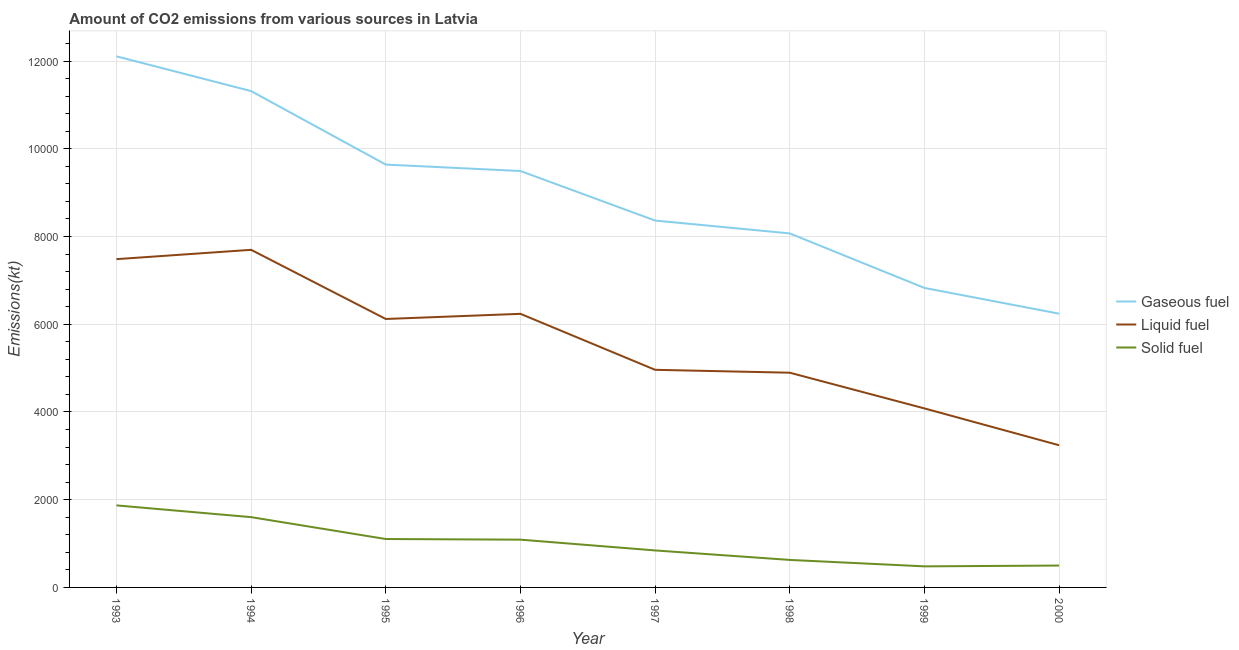What is the amount of co2 emissions from solid fuel in 1998?
Offer a terse response. 627.06. Across all years, what is the maximum amount of co2 emissions from gaseous fuel?
Give a very brief answer. 1.21e+04. Across all years, what is the minimum amount of co2 emissions from gaseous fuel?
Your response must be concise. 6241.23. In which year was the amount of co2 emissions from solid fuel minimum?
Make the answer very short. 1999. What is the total amount of co2 emissions from gaseous fuel in the graph?
Offer a terse response. 7.21e+04. What is the difference between the amount of co2 emissions from solid fuel in 1997 and that in 1999?
Your answer should be compact. 363.03. What is the difference between the amount of co2 emissions from solid fuel in 1994 and the amount of co2 emissions from gaseous fuel in 1998?
Keep it short and to the point. -6468.59. What is the average amount of co2 emissions from gaseous fuel per year?
Keep it short and to the point. 9007.99. In the year 1996, what is the difference between the amount of co2 emissions from solid fuel and amount of co2 emissions from liquid fuel?
Offer a very short reply. -5148.47. In how many years, is the amount of co2 emissions from liquid fuel greater than 12000 kt?
Keep it short and to the point. 0. What is the ratio of the amount of co2 emissions from gaseous fuel in 1994 to that in 1995?
Provide a short and direct response. 1.17. Is the amount of co2 emissions from liquid fuel in 1998 less than that in 1999?
Provide a succinct answer. No. Is the difference between the amount of co2 emissions from gaseous fuel in 1994 and 1997 greater than the difference between the amount of co2 emissions from solid fuel in 1994 and 1997?
Your answer should be compact. Yes. What is the difference between the highest and the second highest amount of co2 emissions from liquid fuel?
Give a very brief answer. 212.69. What is the difference between the highest and the lowest amount of co2 emissions from solid fuel?
Your response must be concise. 1389.79. Is the sum of the amount of co2 emissions from liquid fuel in 1995 and 1997 greater than the maximum amount of co2 emissions from solid fuel across all years?
Offer a terse response. Yes. Is the amount of co2 emissions from gaseous fuel strictly greater than the amount of co2 emissions from solid fuel over the years?
Ensure brevity in your answer.  Yes. What is the difference between two consecutive major ticks on the Y-axis?
Your answer should be compact. 2000. Are the values on the major ticks of Y-axis written in scientific E-notation?
Give a very brief answer. No. Does the graph contain any zero values?
Provide a short and direct response. No. Where does the legend appear in the graph?
Your answer should be very brief. Center right. How many legend labels are there?
Offer a very short reply. 3. What is the title of the graph?
Offer a terse response. Amount of CO2 emissions from various sources in Latvia. Does "Oil" appear as one of the legend labels in the graph?
Your answer should be compact. No. What is the label or title of the X-axis?
Your response must be concise. Year. What is the label or title of the Y-axis?
Keep it short and to the point. Emissions(kt). What is the Emissions(kt) in Gaseous fuel in 1993?
Keep it short and to the point. 1.21e+04. What is the Emissions(kt) of Liquid fuel in 1993?
Your response must be concise. 7484.35. What is the Emissions(kt) of Solid fuel in 1993?
Offer a very short reply. 1870.17. What is the Emissions(kt) of Gaseous fuel in 1994?
Provide a short and direct response. 1.13e+04. What is the Emissions(kt) in Liquid fuel in 1994?
Offer a terse response. 7697.03. What is the Emissions(kt) of Solid fuel in 1994?
Make the answer very short. 1602.48. What is the Emissions(kt) of Gaseous fuel in 1995?
Your response must be concise. 9640.54. What is the Emissions(kt) of Liquid fuel in 1995?
Provide a succinct answer. 6120.22. What is the Emissions(kt) in Solid fuel in 1995?
Offer a terse response. 1103.77. What is the Emissions(kt) of Gaseous fuel in 1996?
Your answer should be very brief. 9493.86. What is the Emissions(kt) in Liquid fuel in 1996?
Provide a succinct answer. 6237.57. What is the Emissions(kt) of Solid fuel in 1996?
Keep it short and to the point. 1089.1. What is the Emissions(kt) in Gaseous fuel in 1997?
Offer a very short reply. 8364.43. What is the Emissions(kt) in Liquid fuel in 1997?
Keep it short and to the point. 4961.45. What is the Emissions(kt) of Solid fuel in 1997?
Your answer should be very brief. 843.41. What is the Emissions(kt) in Gaseous fuel in 1998?
Give a very brief answer. 8071.07. What is the Emissions(kt) in Liquid fuel in 1998?
Keep it short and to the point. 4895.44. What is the Emissions(kt) of Solid fuel in 1998?
Your response must be concise. 627.06. What is the Emissions(kt) in Gaseous fuel in 1999?
Your answer should be compact. 6827.95. What is the Emissions(kt) in Liquid fuel in 1999?
Give a very brief answer. 4081.37. What is the Emissions(kt) of Solid fuel in 1999?
Keep it short and to the point. 480.38. What is the Emissions(kt) of Gaseous fuel in 2000?
Your response must be concise. 6241.23. What is the Emissions(kt) in Liquid fuel in 2000?
Give a very brief answer. 3241.63. What is the Emissions(kt) in Solid fuel in 2000?
Your answer should be very brief. 498.71. Across all years, what is the maximum Emissions(kt) of Gaseous fuel?
Your response must be concise. 1.21e+04. Across all years, what is the maximum Emissions(kt) of Liquid fuel?
Give a very brief answer. 7697.03. Across all years, what is the maximum Emissions(kt) in Solid fuel?
Offer a very short reply. 1870.17. Across all years, what is the minimum Emissions(kt) in Gaseous fuel?
Ensure brevity in your answer.  6241.23. Across all years, what is the minimum Emissions(kt) of Liquid fuel?
Your response must be concise. 3241.63. Across all years, what is the minimum Emissions(kt) in Solid fuel?
Offer a very short reply. 480.38. What is the total Emissions(kt) of Gaseous fuel in the graph?
Make the answer very short. 7.21e+04. What is the total Emissions(kt) in Liquid fuel in the graph?
Offer a terse response. 4.47e+04. What is the total Emissions(kt) in Solid fuel in the graph?
Your answer should be very brief. 8115.07. What is the difference between the Emissions(kt) in Gaseous fuel in 1993 and that in 1994?
Offer a very short reply. 792.07. What is the difference between the Emissions(kt) of Liquid fuel in 1993 and that in 1994?
Your answer should be compact. -212.69. What is the difference between the Emissions(kt) in Solid fuel in 1993 and that in 1994?
Your answer should be very brief. 267.69. What is the difference between the Emissions(kt) of Gaseous fuel in 1993 and that in 1995?
Ensure brevity in your answer.  2467.89. What is the difference between the Emissions(kt) in Liquid fuel in 1993 and that in 1995?
Offer a very short reply. 1364.12. What is the difference between the Emissions(kt) in Solid fuel in 1993 and that in 1995?
Offer a terse response. 766.4. What is the difference between the Emissions(kt) of Gaseous fuel in 1993 and that in 1996?
Your answer should be compact. 2614.57. What is the difference between the Emissions(kt) of Liquid fuel in 1993 and that in 1996?
Ensure brevity in your answer.  1246.78. What is the difference between the Emissions(kt) in Solid fuel in 1993 and that in 1996?
Provide a short and direct response. 781.07. What is the difference between the Emissions(kt) in Gaseous fuel in 1993 and that in 1997?
Offer a very short reply. 3744.01. What is the difference between the Emissions(kt) in Liquid fuel in 1993 and that in 1997?
Give a very brief answer. 2522.9. What is the difference between the Emissions(kt) of Solid fuel in 1993 and that in 1997?
Make the answer very short. 1026.76. What is the difference between the Emissions(kt) in Gaseous fuel in 1993 and that in 1998?
Offer a very short reply. 4037.37. What is the difference between the Emissions(kt) of Liquid fuel in 1993 and that in 1998?
Your answer should be compact. 2588.9. What is the difference between the Emissions(kt) of Solid fuel in 1993 and that in 1998?
Ensure brevity in your answer.  1243.11. What is the difference between the Emissions(kt) of Gaseous fuel in 1993 and that in 1999?
Offer a terse response. 5280.48. What is the difference between the Emissions(kt) of Liquid fuel in 1993 and that in 1999?
Your answer should be compact. 3402.98. What is the difference between the Emissions(kt) of Solid fuel in 1993 and that in 1999?
Provide a succinct answer. 1389.79. What is the difference between the Emissions(kt) of Gaseous fuel in 1993 and that in 2000?
Your answer should be compact. 5867.2. What is the difference between the Emissions(kt) in Liquid fuel in 1993 and that in 2000?
Offer a very short reply. 4242.72. What is the difference between the Emissions(kt) in Solid fuel in 1993 and that in 2000?
Provide a succinct answer. 1371.46. What is the difference between the Emissions(kt) in Gaseous fuel in 1994 and that in 1995?
Your response must be concise. 1675.82. What is the difference between the Emissions(kt) of Liquid fuel in 1994 and that in 1995?
Make the answer very short. 1576.81. What is the difference between the Emissions(kt) in Solid fuel in 1994 and that in 1995?
Your answer should be very brief. 498.71. What is the difference between the Emissions(kt) in Gaseous fuel in 1994 and that in 1996?
Provide a succinct answer. 1822.5. What is the difference between the Emissions(kt) of Liquid fuel in 1994 and that in 1996?
Ensure brevity in your answer.  1459.47. What is the difference between the Emissions(kt) in Solid fuel in 1994 and that in 1996?
Ensure brevity in your answer.  513.38. What is the difference between the Emissions(kt) in Gaseous fuel in 1994 and that in 1997?
Your response must be concise. 2951.93. What is the difference between the Emissions(kt) of Liquid fuel in 1994 and that in 1997?
Provide a short and direct response. 2735.58. What is the difference between the Emissions(kt) of Solid fuel in 1994 and that in 1997?
Make the answer very short. 759.07. What is the difference between the Emissions(kt) of Gaseous fuel in 1994 and that in 1998?
Provide a short and direct response. 3245.3. What is the difference between the Emissions(kt) in Liquid fuel in 1994 and that in 1998?
Give a very brief answer. 2801.59. What is the difference between the Emissions(kt) in Solid fuel in 1994 and that in 1998?
Ensure brevity in your answer.  975.42. What is the difference between the Emissions(kt) in Gaseous fuel in 1994 and that in 1999?
Give a very brief answer. 4488.41. What is the difference between the Emissions(kt) of Liquid fuel in 1994 and that in 1999?
Offer a terse response. 3615.66. What is the difference between the Emissions(kt) of Solid fuel in 1994 and that in 1999?
Give a very brief answer. 1122.1. What is the difference between the Emissions(kt) in Gaseous fuel in 1994 and that in 2000?
Offer a terse response. 5075.13. What is the difference between the Emissions(kt) of Liquid fuel in 1994 and that in 2000?
Make the answer very short. 4455.4. What is the difference between the Emissions(kt) of Solid fuel in 1994 and that in 2000?
Provide a short and direct response. 1103.77. What is the difference between the Emissions(kt) in Gaseous fuel in 1995 and that in 1996?
Give a very brief answer. 146.68. What is the difference between the Emissions(kt) of Liquid fuel in 1995 and that in 1996?
Offer a terse response. -117.34. What is the difference between the Emissions(kt) of Solid fuel in 1995 and that in 1996?
Your response must be concise. 14.67. What is the difference between the Emissions(kt) of Gaseous fuel in 1995 and that in 1997?
Your answer should be compact. 1276.12. What is the difference between the Emissions(kt) in Liquid fuel in 1995 and that in 1997?
Your answer should be compact. 1158.77. What is the difference between the Emissions(kt) in Solid fuel in 1995 and that in 1997?
Ensure brevity in your answer.  260.36. What is the difference between the Emissions(kt) in Gaseous fuel in 1995 and that in 1998?
Offer a very short reply. 1569.48. What is the difference between the Emissions(kt) in Liquid fuel in 1995 and that in 1998?
Ensure brevity in your answer.  1224.78. What is the difference between the Emissions(kt) in Solid fuel in 1995 and that in 1998?
Provide a succinct answer. 476.71. What is the difference between the Emissions(kt) in Gaseous fuel in 1995 and that in 1999?
Ensure brevity in your answer.  2812.59. What is the difference between the Emissions(kt) of Liquid fuel in 1995 and that in 1999?
Ensure brevity in your answer.  2038.85. What is the difference between the Emissions(kt) in Solid fuel in 1995 and that in 1999?
Ensure brevity in your answer.  623.39. What is the difference between the Emissions(kt) of Gaseous fuel in 1995 and that in 2000?
Your answer should be compact. 3399.31. What is the difference between the Emissions(kt) of Liquid fuel in 1995 and that in 2000?
Provide a succinct answer. 2878.59. What is the difference between the Emissions(kt) of Solid fuel in 1995 and that in 2000?
Provide a succinct answer. 605.05. What is the difference between the Emissions(kt) in Gaseous fuel in 1996 and that in 1997?
Provide a short and direct response. 1129.44. What is the difference between the Emissions(kt) in Liquid fuel in 1996 and that in 1997?
Your answer should be very brief. 1276.12. What is the difference between the Emissions(kt) in Solid fuel in 1996 and that in 1997?
Your answer should be very brief. 245.69. What is the difference between the Emissions(kt) of Gaseous fuel in 1996 and that in 1998?
Your answer should be very brief. 1422.8. What is the difference between the Emissions(kt) of Liquid fuel in 1996 and that in 1998?
Give a very brief answer. 1342.12. What is the difference between the Emissions(kt) of Solid fuel in 1996 and that in 1998?
Offer a terse response. 462.04. What is the difference between the Emissions(kt) of Gaseous fuel in 1996 and that in 1999?
Keep it short and to the point. 2665.91. What is the difference between the Emissions(kt) in Liquid fuel in 1996 and that in 1999?
Your answer should be compact. 2156.2. What is the difference between the Emissions(kt) in Solid fuel in 1996 and that in 1999?
Your answer should be compact. 608.72. What is the difference between the Emissions(kt) of Gaseous fuel in 1996 and that in 2000?
Offer a terse response. 3252.63. What is the difference between the Emissions(kt) of Liquid fuel in 1996 and that in 2000?
Offer a terse response. 2995.94. What is the difference between the Emissions(kt) of Solid fuel in 1996 and that in 2000?
Provide a short and direct response. 590.39. What is the difference between the Emissions(kt) of Gaseous fuel in 1997 and that in 1998?
Ensure brevity in your answer.  293.36. What is the difference between the Emissions(kt) of Liquid fuel in 1997 and that in 1998?
Your response must be concise. 66.01. What is the difference between the Emissions(kt) in Solid fuel in 1997 and that in 1998?
Make the answer very short. 216.35. What is the difference between the Emissions(kt) in Gaseous fuel in 1997 and that in 1999?
Your answer should be very brief. 1536.47. What is the difference between the Emissions(kt) of Liquid fuel in 1997 and that in 1999?
Give a very brief answer. 880.08. What is the difference between the Emissions(kt) of Solid fuel in 1997 and that in 1999?
Make the answer very short. 363.03. What is the difference between the Emissions(kt) in Gaseous fuel in 1997 and that in 2000?
Your answer should be compact. 2123.19. What is the difference between the Emissions(kt) of Liquid fuel in 1997 and that in 2000?
Your response must be concise. 1719.82. What is the difference between the Emissions(kt) in Solid fuel in 1997 and that in 2000?
Your answer should be compact. 344.7. What is the difference between the Emissions(kt) of Gaseous fuel in 1998 and that in 1999?
Your response must be concise. 1243.11. What is the difference between the Emissions(kt) of Liquid fuel in 1998 and that in 1999?
Offer a very short reply. 814.07. What is the difference between the Emissions(kt) of Solid fuel in 1998 and that in 1999?
Give a very brief answer. 146.68. What is the difference between the Emissions(kt) of Gaseous fuel in 1998 and that in 2000?
Provide a succinct answer. 1829.83. What is the difference between the Emissions(kt) of Liquid fuel in 1998 and that in 2000?
Provide a succinct answer. 1653.82. What is the difference between the Emissions(kt) of Solid fuel in 1998 and that in 2000?
Offer a terse response. 128.34. What is the difference between the Emissions(kt) in Gaseous fuel in 1999 and that in 2000?
Offer a very short reply. 586.72. What is the difference between the Emissions(kt) of Liquid fuel in 1999 and that in 2000?
Give a very brief answer. 839.74. What is the difference between the Emissions(kt) of Solid fuel in 1999 and that in 2000?
Offer a terse response. -18.34. What is the difference between the Emissions(kt) in Gaseous fuel in 1993 and the Emissions(kt) in Liquid fuel in 1994?
Offer a terse response. 4411.4. What is the difference between the Emissions(kt) of Gaseous fuel in 1993 and the Emissions(kt) of Solid fuel in 1994?
Your response must be concise. 1.05e+04. What is the difference between the Emissions(kt) of Liquid fuel in 1993 and the Emissions(kt) of Solid fuel in 1994?
Make the answer very short. 5881.87. What is the difference between the Emissions(kt) of Gaseous fuel in 1993 and the Emissions(kt) of Liquid fuel in 1995?
Your response must be concise. 5988.21. What is the difference between the Emissions(kt) in Gaseous fuel in 1993 and the Emissions(kt) in Solid fuel in 1995?
Make the answer very short. 1.10e+04. What is the difference between the Emissions(kt) in Liquid fuel in 1993 and the Emissions(kt) in Solid fuel in 1995?
Provide a short and direct response. 6380.58. What is the difference between the Emissions(kt) in Gaseous fuel in 1993 and the Emissions(kt) in Liquid fuel in 1996?
Your response must be concise. 5870.87. What is the difference between the Emissions(kt) in Gaseous fuel in 1993 and the Emissions(kt) in Solid fuel in 1996?
Ensure brevity in your answer.  1.10e+04. What is the difference between the Emissions(kt) in Liquid fuel in 1993 and the Emissions(kt) in Solid fuel in 1996?
Provide a succinct answer. 6395.25. What is the difference between the Emissions(kt) in Gaseous fuel in 1993 and the Emissions(kt) in Liquid fuel in 1997?
Provide a short and direct response. 7146.98. What is the difference between the Emissions(kt) of Gaseous fuel in 1993 and the Emissions(kt) of Solid fuel in 1997?
Give a very brief answer. 1.13e+04. What is the difference between the Emissions(kt) in Liquid fuel in 1993 and the Emissions(kt) in Solid fuel in 1997?
Your answer should be very brief. 6640.94. What is the difference between the Emissions(kt) of Gaseous fuel in 1993 and the Emissions(kt) of Liquid fuel in 1998?
Ensure brevity in your answer.  7212.99. What is the difference between the Emissions(kt) of Gaseous fuel in 1993 and the Emissions(kt) of Solid fuel in 1998?
Provide a succinct answer. 1.15e+04. What is the difference between the Emissions(kt) in Liquid fuel in 1993 and the Emissions(kt) in Solid fuel in 1998?
Keep it short and to the point. 6857.29. What is the difference between the Emissions(kt) in Gaseous fuel in 1993 and the Emissions(kt) in Liquid fuel in 1999?
Give a very brief answer. 8027.06. What is the difference between the Emissions(kt) in Gaseous fuel in 1993 and the Emissions(kt) in Solid fuel in 1999?
Make the answer very short. 1.16e+04. What is the difference between the Emissions(kt) of Liquid fuel in 1993 and the Emissions(kt) of Solid fuel in 1999?
Provide a short and direct response. 7003.97. What is the difference between the Emissions(kt) in Gaseous fuel in 1993 and the Emissions(kt) in Liquid fuel in 2000?
Offer a very short reply. 8866.81. What is the difference between the Emissions(kt) in Gaseous fuel in 1993 and the Emissions(kt) in Solid fuel in 2000?
Offer a terse response. 1.16e+04. What is the difference between the Emissions(kt) in Liquid fuel in 1993 and the Emissions(kt) in Solid fuel in 2000?
Provide a short and direct response. 6985.64. What is the difference between the Emissions(kt) in Gaseous fuel in 1994 and the Emissions(kt) in Liquid fuel in 1995?
Keep it short and to the point. 5196.14. What is the difference between the Emissions(kt) of Gaseous fuel in 1994 and the Emissions(kt) of Solid fuel in 1995?
Give a very brief answer. 1.02e+04. What is the difference between the Emissions(kt) in Liquid fuel in 1994 and the Emissions(kt) in Solid fuel in 1995?
Make the answer very short. 6593.27. What is the difference between the Emissions(kt) of Gaseous fuel in 1994 and the Emissions(kt) of Liquid fuel in 1996?
Your answer should be compact. 5078.8. What is the difference between the Emissions(kt) in Gaseous fuel in 1994 and the Emissions(kt) in Solid fuel in 1996?
Ensure brevity in your answer.  1.02e+04. What is the difference between the Emissions(kt) in Liquid fuel in 1994 and the Emissions(kt) in Solid fuel in 1996?
Your response must be concise. 6607.93. What is the difference between the Emissions(kt) of Gaseous fuel in 1994 and the Emissions(kt) of Liquid fuel in 1997?
Provide a succinct answer. 6354.91. What is the difference between the Emissions(kt) of Gaseous fuel in 1994 and the Emissions(kt) of Solid fuel in 1997?
Your response must be concise. 1.05e+04. What is the difference between the Emissions(kt) of Liquid fuel in 1994 and the Emissions(kt) of Solid fuel in 1997?
Give a very brief answer. 6853.62. What is the difference between the Emissions(kt) of Gaseous fuel in 1994 and the Emissions(kt) of Liquid fuel in 1998?
Provide a short and direct response. 6420.92. What is the difference between the Emissions(kt) in Gaseous fuel in 1994 and the Emissions(kt) in Solid fuel in 1998?
Your answer should be very brief. 1.07e+04. What is the difference between the Emissions(kt) of Liquid fuel in 1994 and the Emissions(kt) of Solid fuel in 1998?
Your response must be concise. 7069.98. What is the difference between the Emissions(kt) in Gaseous fuel in 1994 and the Emissions(kt) in Liquid fuel in 1999?
Ensure brevity in your answer.  7234.99. What is the difference between the Emissions(kt) in Gaseous fuel in 1994 and the Emissions(kt) in Solid fuel in 1999?
Your answer should be compact. 1.08e+04. What is the difference between the Emissions(kt) in Liquid fuel in 1994 and the Emissions(kt) in Solid fuel in 1999?
Offer a terse response. 7216.66. What is the difference between the Emissions(kt) of Gaseous fuel in 1994 and the Emissions(kt) of Liquid fuel in 2000?
Offer a very short reply. 8074.73. What is the difference between the Emissions(kt) in Gaseous fuel in 1994 and the Emissions(kt) in Solid fuel in 2000?
Make the answer very short. 1.08e+04. What is the difference between the Emissions(kt) of Liquid fuel in 1994 and the Emissions(kt) of Solid fuel in 2000?
Your answer should be very brief. 7198.32. What is the difference between the Emissions(kt) of Gaseous fuel in 1995 and the Emissions(kt) of Liquid fuel in 1996?
Offer a terse response. 3402.98. What is the difference between the Emissions(kt) of Gaseous fuel in 1995 and the Emissions(kt) of Solid fuel in 1996?
Offer a very short reply. 8551.44. What is the difference between the Emissions(kt) of Liquid fuel in 1995 and the Emissions(kt) of Solid fuel in 1996?
Ensure brevity in your answer.  5031.12. What is the difference between the Emissions(kt) of Gaseous fuel in 1995 and the Emissions(kt) of Liquid fuel in 1997?
Your response must be concise. 4679.09. What is the difference between the Emissions(kt) of Gaseous fuel in 1995 and the Emissions(kt) of Solid fuel in 1997?
Provide a short and direct response. 8797.13. What is the difference between the Emissions(kt) of Liquid fuel in 1995 and the Emissions(kt) of Solid fuel in 1997?
Provide a succinct answer. 5276.81. What is the difference between the Emissions(kt) in Gaseous fuel in 1995 and the Emissions(kt) in Liquid fuel in 1998?
Ensure brevity in your answer.  4745.1. What is the difference between the Emissions(kt) of Gaseous fuel in 1995 and the Emissions(kt) of Solid fuel in 1998?
Ensure brevity in your answer.  9013.49. What is the difference between the Emissions(kt) of Liquid fuel in 1995 and the Emissions(kt) of Solid fuel in 1998?
Offer a terse response. 5493.17. What is the difference between the Emissions(kt) in Gaseous fuel in 1995 and the Emissions(kt) in Liquid fuel in 1999?
Your answer should be compact. 5559.17. What is the difference between the Emissions(kt) of Gaseous fuel in 1995 and the Emissions(kt) of Solid fuel in 1999?
Provide a short and direct response. 9160.17. What is the difference between the Emissions(kt) in Liquid fuel in 1995 and the Emissions(kt) in Solid fuel in 1999?
Provide a short and direct response. 5639.85. What is the difference between the Emissions(kt) of Gaseous fuel in 1995 and the Emissions(kt) of Liquid fuel in 2000?
Offer a terse response. 6398.91. What is the difference between the Emissions(kt) of Gaseous fuel in 1995 and the Emissions(kt) of Solid fuel in 2000?
Give a very brief answer. 9141.83. What is the difference between the Emissions(kt) of Liquid fuel in 1995 and the Emissions(kt) of Solid fuel in 2000?
Give a very brief answer. 5621.51. What is the difference between the Emissions(kt) in Gaseous fuel in 1996 and the Emissions(kt) in Liquid fuel in 1997?
Ensure brevity in your answer.  4532.41. What is the difference between the Emissions(kt) in Gaseous fuel in 1996 and the Emissions(kt) in Solid fuel in 1997?
Ensure brevity in your answer.  8650.45. What is the difference between the Emissions(kt) of Liquid fuel in 1996 and the Emissions(kt) of Solid fuel in 1997?
Provide a short and direct response. 5394.16. What is the difference between the Emissions(kt) in Gaseous fuel in 1996 and the Emissions(kt) in Liquid fuel in 1998?
Ensure brevity in your answer.  4598.42. What is the difference between the Emissions(kt) in Gaseous fuel in 1996 and the Emissions(kt) in Solid fuel in 1998?
Offer a terse response. 8866.81. What is the difference between the Emissions(kt) in Liquid fuel in 1996 and the Emissions(kt) in Solid fuel in 1998?
Provide a succinct answer. 5610.51. What is the difference between the Emissions(kt) of Gaseous fuel in 1996 and the Emissions(kt) of Liquid fuel in 1999?
Offer a very short reply. 5412.49. What is the difference between the Emissions(kt) in Gaseous fuel in 1996 and the Emissions(kt) in Solid fuel in 1999?
Provide a short and direct response. 9013.49. What is the difference between the Emissions(kt) in Liquid fuel in 1996 and the Emissions(kt) in Solid fuel in 1999?
Offer a terse response. 5757.19. What is the difference between the Emissions(kt) of Gaseous fuel in 1996 and the Emissions(kt) of Liquid fuel in 2000?
Ensure brevity in your answer.  6252.23. What is the difference between the Emissions(kt) of Gaseous fuel in 1996 and the Emissions(kt) of Solid fuel in 2000?
Your answer should be very brief. 8995.15. What is the difference between the Emissions(kt) of Liquid fuel in 1996 and the Emissions(kt) of Solid fuel in 2000?
Provide a short and direct response. 5738.85. What is the difference between the Emissions(kt) in Gaseous fuel in 1997 and the Emissions(kt) in Liquid fuel in 1998?
Offer a terse response. 3468.98. What is the difference between the Emissions(kt) of Gaseous fuel in 1997 and the Emissions(kt) of Solid fuel in 1998?
Keep it short and to the point. 7737.37. What is the difference between the Emissions(kt) of Liquid fuel in 1997 and the Emissions(kt) of Solid fuel in 1998?
Ensure brevity in your answer.  4334.39. What is the difference between the Emissions(kt) in Gaseous fuel in 1997 and the Emissions(kt) in Liquid fuel in 1999?
Your response must be concise. 4283.06. What is the difference between the Emissions(kt) in Gaseous fuel in 1997 and the Emissions(kt) in Solid fuel in 1999?
Your answer should be compact. 7884.05. What is the difference between the Emissions(kt) in Liquid fuel in 1997 and the Emissions(kt) in Solid fuel in 1999?
Keep it short and to the point. 4481.07. What is the difference between the Emissions(kt) of Gaseous fuel in 1997 and the Emissions(kt) of Liquid fuel in 2000?
Ensure brevity in your answer.  5122.8. What is the difference between the Emissions(kt) in Gaseous fuel in 1997 and the Emissions(kt) in Solid fuel in 2000?
Your answer should be very brief. 7865.72. What is the difference between the Emissions(kt) in Liquid fuel in 1997 and the Emissions(kt) in Solid fuel in 2000?
Ensure brevity in your answer.  4462.74. What is the difference between the Emissions(kt) of Gaseous fuel in 1998 and the Emissions(kt) of Liquid fuel in 1999?
Give a very brief answer. 3989.7. What is the difference between the Emissions(kt) in Gaseous fuel in 1998 and the Emissions(kt) in Solid fuel in 1999?
Offer a terse response. 7590.69. What is the difference between the Emissions(kt) in Liquid fuel in 1998 and the Emissions(kt) in Solid fuel in 1999?
Provide a short and direct response. 4415.07. What is the difference between the Emissions(kt) in Gaseous fuel in 1998 and the Emissions(kt) in Liquid fuel in 2000?
Your response must be concise. 4829.44. What is the difference between the Emissions(kt) of Gaseous fuel in 1998 and the Emissions(kt) of Solid fuel in 2000?
Your response must be concise. 7572.35. What is the difference between the Emissions(kt) in Liquid fuel in 1998 and the Emissions(kt) in Solid fuel in 2000?
Provide a succinct answer. 4396.73. What is the difference between the Emissions(kt) in Gaseous fuel in 1999 and the Emissions(kt) in Liquid fuel in 2000?
Your answer should be compact. 3586.33. What is the difference between the Emissions(kt) of Gaseous fuel in 1999 and the Emissions(kt) of Solid fuel in 2000?
Keep it short and to the point. 6329.24. What is the difference between the Emissions(kt) of Liquid fuel in 1999 and the Emissions(kt) of Solid fuel in 2000?
Provide a succinct answer. 3582.66. What is the average Emissions(kt) in Gaseous fuel per year?
Ensure brevity in your answer.  9007.99. What is the average Emissions(kt) in Liquid fuel per year?
Offer a terse response. 5589.88. What is the average Emissions(kt) in Solid fuel per year?
Your answer should be compact. 1014.38. In the year 1993, what is the difference between the Emissions(kt) in Gaseous fuel and Emissions(kt) in Liquid fuel?
Provide a succinct answer. 4624.09. In the year 1993, what is the difference between the Emissions(kt) in Gaseous fuel and Emissions(kt) in Solid fuel?
Provide a succinct answer. 1.02e+04. In the year 1993, what is the difference between the Emissions(kt) in Liquid fuel and Emissions(kt) in Solid fuel?
Offer a very short reply. 5614.18. In the year 1994, what is the difference between the Emissions(kt) of Gaseous fuel and Emissions(kt) of Liquid fuel?
Your answer should be compact. 3619.33. In the year 1994, what is the difference between the Emissions(kt) in Gaseous fuel and Emissions(kt) in Solid fuel?
Offer a very short reply. 9713.88. In the year 1994, what is the difference between the Emissions(kt) in Liquid fuel and Emissions(kt) in Solid fuel?
Your answer should be very brief. 6094.55. In the year 1995, what is the difference between the Emissions(kt) in Gaseous fuel and Emissions(kt) in Liquid fuel?
Keep it short and to the point. 3520.32. In the year 1995, what is the difference between the Emissions(kt) in Gaseous fuel and Emissions(kt) in Solid fuel?
Provide a short and direct response. 8536.78. In the year 1995, what is the difference between the Emissions(kt) in Liquid fuel and Emissions(kt) in Solid fuel?
Your answer should be very brief. 5016.46. In the year 1996, what is the difference between the Emissions(kt) of Gaseous fuel and Emissions(kt) of Liquid fuel?
Keep it short and to the point. 3256.3. In the year 1996, what is the difference between the Emissions(kt) of Gaseous fuel and Emissions(kt) of Solid fuel?
Keep it short and to the point. 8404.76. In the year 1996, what is the difference between the Emissions(kt) in Liquid fuel and Emissions(kt) in Solid fuel?
Provide a short and direct response. 5148.47. In the year 1997, what is the difference between the Emissions(kt) in Gaseous fuel and Emissions(kt) in Liquid fuel?
Give a very brief answer. 3402.98. In the year 1997, what is the difference between the Emissions(kt) in Gaseous fuel and Emissions(kt) in Solid fuel?
Give a very brief answer. 7521.02. In the year 1997, what is the difference between the Emissions(kt) in Liquid fuel and Emissions(kt) in Solid fuel?
Make the answer very short. 4118.04. In the year 1998, what is the difference between the Emissions(kt) in Gaseous fuel and Emissions(kt) in Liquid fuel?
Give a very brief answer. 3175.62. In the year 1998, what is the difference between the Emissions(kt) in Gaseous fuel and Emissions(kt) in Solid fuel?
Provide a succinct answer. 7444.01. In the year 1998, what is the difference between the Emissions(kt) of Liquid fuel and Emissions(kt) of Solid fuel?
Your answer should be very brief. 4268.39. In the year 1999, what is the difference between the Emissions(kt) of Gaseous fuel and Emissions(kt) of Liquid fuel?
Offer a very short reply. 2746.58. In the year 1999, what is the difference between the Emissions(kt) of Gaseous fuel and Emissions(kt) of Solid fuel?
Offer a terse response. 6347.58. In the year 1999, what is the difference between the Emissions(kt) in Liquid fuel and Emissions(kt) in Solid fuel?
Ensure brevity in your answer.  3600.99. In the year 2000, what is the difference between the Emissions(kt) in Gaseous fuel and Emissions(kt) in Liquid fuel?
Give a very brief answer. 2999.61. In the year 2000, what is the difference between the Emissions(kt) in Gaseous fuel and Emissions(kt) in Solid fuel?
Give a very brief answer. 5742.52. In the year 2000, what is the difference between the Emissions(kt) of Liquid fuel and Emissions(kt) of Solid fuel?
Offer a very short reply. 2742.92. What is the ratio of the Emissions(kt) of Gaseous fuel in 1993 to that in 1994?
Offer a very short reply. 1.07. What is the ratio of the Emissions(kt) in Liquid fuel in 1993 to that in 1994?
Keep it short and to the point. 0.97. What is the ratio of the Emissions(kt) in Solid fuel in 1993 to that in 1994?
Offer a terse response. 1.17. What is the ratio of the Emissions(kt) of Gaseous fuel in 1993 to that in 1995?
Give a very brief answer. 1.26. What is the ratio of the Emissions(kt) of Liquid fuel in 1993 to that in 1995?
Provide a succinct answer. 1.22. What is the ratio of the Emissions(kt) in Solid fuel in 1993 to that in 1995?
Offer a terse response. 1.69. What is the ratio of the Emissions(kt) in Gaseous fuel in 1993 to that in 1996?
Offer a very short reply. 1.28. What is the ratio of the Emissions(kt) in Liquid fuel in 1993 to that in 1996?
Provide a short and direct response. 1.2. What is the ratio of the Emissions(kt) in Solid fuel in 1993 to that in 1996?
Offer a very short reply. 1.72. What is the ratio of the Emissions(kt) of Gaseous fuel in 1993 to that in 1997?
Provide a succinct answer. 1.45. What is the ratio of the Emissions(kt) in Liquid fuel in 1993 to that in 1997?
Offer a terse response. 1.51. What is the ratio of the Emissions(kt) in Solid fuel in 1993 to that in 1997?
Offer a terse response. 2.22. What is the ratio of the Emissions(kt) of Gaseous fuel in 1993 to that in 1998?
Your answer should be very brief. 1.5. What is the ratio of the Emissions(kt) of Liquid fuel in 1993 to that in 1998?
Make the answer very short. 1.53. What is the ratio of the Emissions(kt) of Solid fuel in 1993 to that in 1998?
Make the answer very short. 2.98. What is the ratio of the Emissions(kt) in Gaseous fuel in 1993 to that in 1999?
Your response must be concise. 1.77. What is the ratio of the Emissions(kt) of Liquid fuel in 1993 to that in 1999?
Provide a short and direct response. 1.83. What is the ratio of the Emissions(kt) of Solid fuel in 1993 to that in 1999?
Your answer should be compact. 3.89. What is the ratio of the Emissions(kt) in Gaseous fuel in 1993 to that in 2000?
Your answer should be compact. 1.94. What is the ratio of the Emissions(kt) of Liquid fuel in 1993 to that in 2000?
Make the answer very short. 2.31. What is the ratio of the Emissions(kt) in Solid fuel in 1993 to that in 2000?
Your answer should be compact. 3.75. What is the ratio of the Emissions(kt) of Gaseous fuel in 1994 to that in 1995?
Your answer should be very brief. 1.17. What is the ratio of the Emissions(kt) in Liquid fuel in 1994 to that in 1995?
Provide a short and direct response. 1.26. What is the ratio of the Emissions(kt) in Solid fuel in 1994 to that in 1995?
Provide a short and direct response. 1.45. What is the ratio of the Emissions(kt) of Gaseous fuel in 1994 to that in 1996?
Ensure brevity in your answer.  1.19. What is the ratio of the Emissions(kt) of Liquid fuel in 1994 to that in 1996?
Your response must be concise. 1.23. What is the ratio of the Emissions(kt) in Solid fuel in 1994 to that in 1996?
Your response must be concise. 1.47. What is the ratio of the Emissions(kt) in Gaseous fuel in 1994 to that in 1997?
Provide a short and direct response. 1.35. What is the ratio of the Emissions(kt) of Liquid fuel in 1994 to that in 1997?
Your answer should be compact. 1.55. What is the ratio of the Emissions(kt) in Gaseous fuel in 1994 to that in 1998?
Your answer should be very brief. 1.4. What is the ratio of the Emissions(kt) in Liquid fuel in 1994 to that in 1998?
Ensure brevity in your answer.  1.57. What is the ratio of the Emissions(kt) in Solid fuel in 1994 to that in 1998?
Provide a short and direct response. 2.56. What is the ratio of the Emissions(kt) of Gaseous fuel in 1994 to that in 1999?
Make the answer very short. 1.66. What is the ratio of the Emissions(kt) in Liquid fuel in 1994 to that in 1999?
Provide a short and direct response. 1.89. What is the ratio of the Emissions(kt) in Solid fuel in 1994 to that in 1999?
Your response must be concise. 3.34. What is the ratio of the Emissions(kt) of Gaseous fuel in 1994 to that in 2000?
Offer a terse response. 1.81. What is the ratio of the Emissions(kt) in Liquid fuel in 1994 to that in 2000?
Keep it short and to the point. 2.37. What is the ratio of the Emissions(kt) of Solid fuel in 1994 to that in 2000?
Provide a succinct answer. 3.21. What is the ratio of the Emissions(kt) of Gaseous fuel in 1995 to that in 1996?
Your response must be concise. 1.02. What is the ratio of the Emissions(kt) of Liquid fuel in 1995 to that in 1996?
Give a very brief answer. 0.98. What is the ratio of the Emissions(kt) of Solid fuel in 1995 to that in 1996?
Your answer should be compact. 1.01. What is the ratio of the Emissions(kt) in Gaseous fuel in 1995 to that in 1997?
Offer a terse response. 1.15. What is the ratio of the Emissions(kt) of Liquid fuel in 1995 to that in 1997?
Your answer should be compact. 1.23. What is the ratio of the Emissions(kt) of Solid fuel in 1995 to that in 1997?
Provide a short and direct response. 1.31. What is the ratio of the Emissions(kt) in Gaseous fuel in 1995 to that in 1998?
Make the answer very short. 1.19. What is the ratio of the Emissions(kt) of Liquid fuel in 1995 to that in 1998?
Provide a short and direct response. 1.25. What is the ratio of the Emissions(kt) of Solid fuel in 1995 to that in 1998?
Offer a terse response. 1.76. What is the ratio of the Emissions(kt) of Gaseous fuel in 1995 to that in 1999?
Your answer should be very brief. 1.41. What is the ratio of the Emissions(kt) of Liquid fuel in 1995 to that in 1999?
Make the answer very short. 1.5. What is the ratio of the Emissions(kt) of Solid fuel in 1995 to that in 1999?
Offer a very short reply. 2.3. What is the ratio of the Emissions(kt) in Gaseous fuel in 1995 to that in 2000?
Offer a very short reply. 1.54. What is the ratio of the Emissions(kt) in Liquid fuel in 1995 to that in 2000?
Your answer should be compact. 1.89. What is the ratio of the Emissions(kt) of Solid fuel in 1995 to that in 2000?
Provide a succinct answer. 2.21. What is the ratio of the Emissions(kt) in Gaseous fuel in 1996 to that in 1997?
Provide a succinct answer. 1.14. What is the ratio of the Emissions(kt) in Liquid fuel in 1996 to that in 1997?
Your answer should be compact. 1.26. What is the ratio of the Emissions(kt) of Solid fuel in 1996 to that in 1997?
Your answer should be compact. 1.29. What is the ratio of the Emissions(kt) of Gaseous fuel in 1996 to that in 1998?
Offer a terse response. 1.18. What is the ratio of the Emissions(kt) of Liquid fuel in 1996 to that in 1998?
Your answer should be compact. 1.27. What is the ratio of the Emissions(kt) of Solid fuel in 1996 to that in 1998?
Provide a short and direct response. 1.74. What is the ratio of the Emissions(kt) of Gaseous fuel in 1996 to that in 1999?
Keep it short and to the point. 1.39. What is the ratio of the Emissions(kt) in Liquid fuel in 1996 to that in 1999?
Ensure brevity in your answer.  1.53. What is the ratio of the Emissions(kt) of Solid fuel in 1996 to that in 1999?
Your answer should be compact. 2.27. What is the ratio of the Emissions(kt) in Gaseous fuel in 1996 to that in 2000?
Your answer should be compact. 1.52. What is the ratio of the Emissions(kt) of Liquid fuel in 1996 to that in 2000?
Provide a short and direct response. 1.92. What is the ratio of the Emissions(kt) in Solid fuel in 1996 to that in 2000?
Your answer should be compact. 2.18. What is the ratio of the Emissions(kt) in Gaseous fuel in 1997 to that in 1998?
Provide a short and direct response. 1.04. What is the ratio of the Emissions(kt) of Liquid fuel in 1997 to that in 1998?
Make the answer very short. 1.01. What is the ratio of the Emissions(kt) of Solid fuel in 1997 to that in 1998?
Offer a terse response. 1.34. What is the ratio of the Emissions(kt) of Gaseous fuel in 1997 to that in 1999?
Give a very brief answer. 1.23. What is the ratio of the Emissions(kt) of Liquid fuel in 1997 to that in 1999?
Your answer should be compact. 1.22. What is the ratio of the Emissions(kt) in Solid fuel in 1997 to that in 1999?
Your response must be concise. 1.76. What is the ratio of the Emissions(kt) of Gaseous fuel in 1997 to that in 2000?
Offer a very short reply. 1.34. What is the ratio of the Emissions(kt) of Liquid fuel in 1997 to that in 2000?
Keep it short and to the point. 1.53. What is the ratio of the Emissions(kt) of Solid fuel in 1997 to that in 2000?
Give a very brief answer. 1.69. What is the ratio of the Emissions(kt) in Gaseous fuel in 1998 to that in 1999?
Your answer should be very brief. 1.18. What is the ratio of the Emissions(kt) of Liquid fuel in 1998 to that in 1999?
Provide a succinct answer. 1.2. What is the ratio of the Emissions(kt) of Solid fuel in 1998 to that in 1999?
Ensure brevity in your answer.  1.31. What is the ratio of the Emissions(kt) of Gaseous fuel in 1998 to that in 2000?
Offer a very short reply. 1.29. What is the ratio of the Emissions(kt) of Liquid fuel in 1998 to that in 2000?
Keep it short and to the point. 1.51. What is the ratio of the Emissions(kt) in Solid fuel in 1998 to that in 2000?
Ensure brevity in your answer.  1.26. What is the ratio of the Emissions(kt) in Gaseous fuel in 1999 to that in 2000?
Offer a terse response. 1.09. What is the ratio of the Emissions(kt) of Liquid fuel in 1999 to that in 2000?
Give a very brief answer. 1.26. What is the ratio of the Emissions(kt) in Solid fuel in 1999 to that in 2000?
Offer a very short reply. 0.96. What is the difference between the highest and the second highest Emissions(kt) of Gaseous fuel?
Keep it short and to the point. 792.07. What is the difference between the highest and the second highest Emissions(kt) in Liquid fuel?
Give a very brief answer. 212.69. What is the difference between the highest and the second highest Emissions(kt) in Solid fuel?
Ensure brevity in your answer.  267.69. What is the difference between the highest and the lowest Emissions(kt) in Gaseous fuel?
Keep it short and to the point. 5867.2. What is the difference between the highest and the lowest Emissions(kt) in Liquid fuel?
Provide a short and direct response. 4455.4. What is the difference between the highest and the lowest Emissions(kt) of Solid fuel?
Keep it short and to the point. 1389.79. 